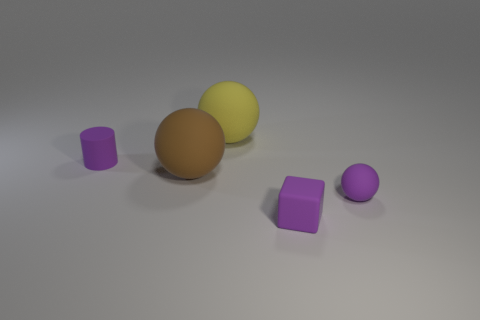Is there any other thing that has the same shape as the big brown thing?
Your answer should be very brief. Yes. What is the size of the yellow object?
Make the answer very short. Large. Is the number of large yellow rubber things on the left side of the large brown rubber thing less than the number of big gray rubber objects?
Provide a succinct answer. No. Do the purple cylinder and the brown sphere have the same size?
Keep it short and to the point. No. What color is the small cylinder that is made of the same material as the small purple sphere?
Provide a succinct answer. Purple. Are there fewer matte cylinders in front of the brown rubber object than rubber balls on the left side of the tiny purple ball?
Your answer should be compact. Yes. What number of balls have the same color as the rubber block?
Provide a short and direct response. 1. What material is the small cylinder that is the same color as the block?
Give a very brief answer. Rubber. How many spheres are both in front of the big yellow matte ball and to the right of the big brown rubber thing?
Your answer should be very brief. 1. What is the material of the big thing that is in front of the matte ball that is behind the purple cylinder?
Keep it short and to the point. Rubber. 